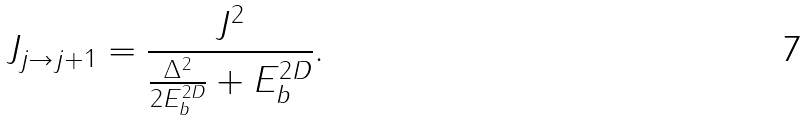Convert formula to latex. <formula><loc_0><loc_0><loc_500><loc_500>J _ { j \rightarrow j + 1 } = \frac { J ^ { 2 } } { \frac { \Delta ^ { 2 } } { 2 E _ { b } ^ { 2 D } } + E ^ { 2 D } _ { b } } .</formula> 